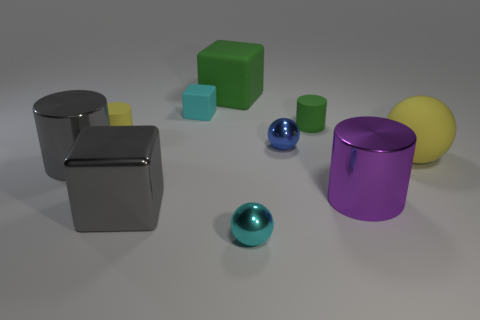Subtract all matte blocks. How many blocks are left? 1 Subtract 1 blocks. How many blocks are left? 2 Subtract all gray cylinders. How many cylinders are left? 3 Subtract all cylinders. How many objects are left? 6 Subtract all purple cylinders. Subtract all brown cubes. How many cylinders are left? 3 Subtract all tiny yellow rubber cylinders. Subtract all big purple shiny cylinders. How many objects are left? 8 Add 1 purple objects. How many purple objects are left? 2 Add 4 small balls. How many small balls exist? 6 Subtract 1 purple cylinders. How many objects are left? 9 